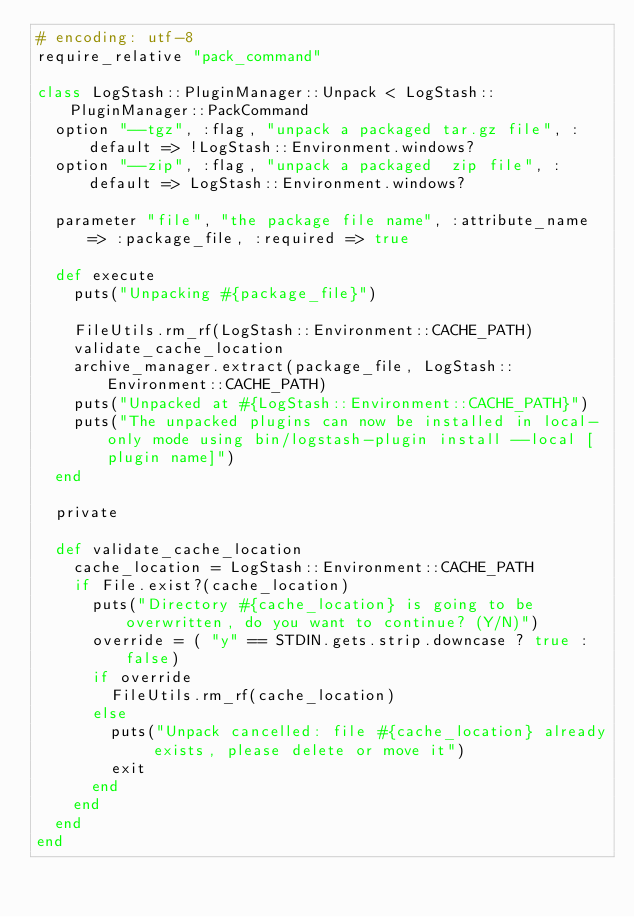<code> <loc_0><loc_0><loc_500><loc_500><_Ruby_># encoding: utf-8
require_relative "pack_command"

class LogStash::PluginManager::Unpack < LogStash::PluginManager::PackCommand
  option "--tgz", :flag, "unpack a packaged tar.gz file", :default => !LogStash::Environment.windows?
  option "--zip", :flag, "unpack a packaged  zip file", :default => LogStash::Environment.windows?

  parameter "file", "the package file name", :attribute_name => :package_file, :required => true

  def execute
    puts("Unpacking #{package_file}")

    FileUtils.rm_rf(LogStash::Environment::CACHE_PATH)
    validate_cache_location
    archive_manager.extract(package_file, LogStash::Environment::CACHE_PATH)
    puts("Unpacked at #{LogStash::Environment::CACHE_PATH}")
    puts("The unpacked plugins can now be installed in local-only mode using bin/logstash-plugin install --local [plugin name]")
  end

  private

  def validate_cache_location
    cache_location = LogStash::Environment::CACHE_PATH
    if File.exist?(cache_location)
      puts("Directory #{cache_location} is going to be overwritten, do you want to continue? (Y/N)")
      override = ( "y" == STDIN.gets.strip.downcase ? true : false)
      if override
        FileUtils.rm_rf(cache_location)
      else
        puts("Unpack cancelled: file #{cache_location} already exists, please delete or move it")
        exit
      end
    end
  end
end
</code> 